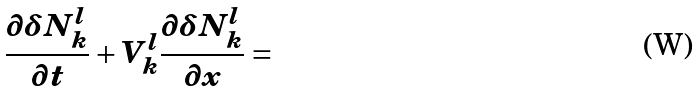Convert formula to latex. <formula><loc_0><loc_0><loc_500><loc_500>\frac { \partial \delta N _ { k } ^ { l } } { \partial t } + { V } ^ { l } _ { k } \frac { \partial \delta N _ { k } ^ { l } } { \partial { x } } =</formula> 